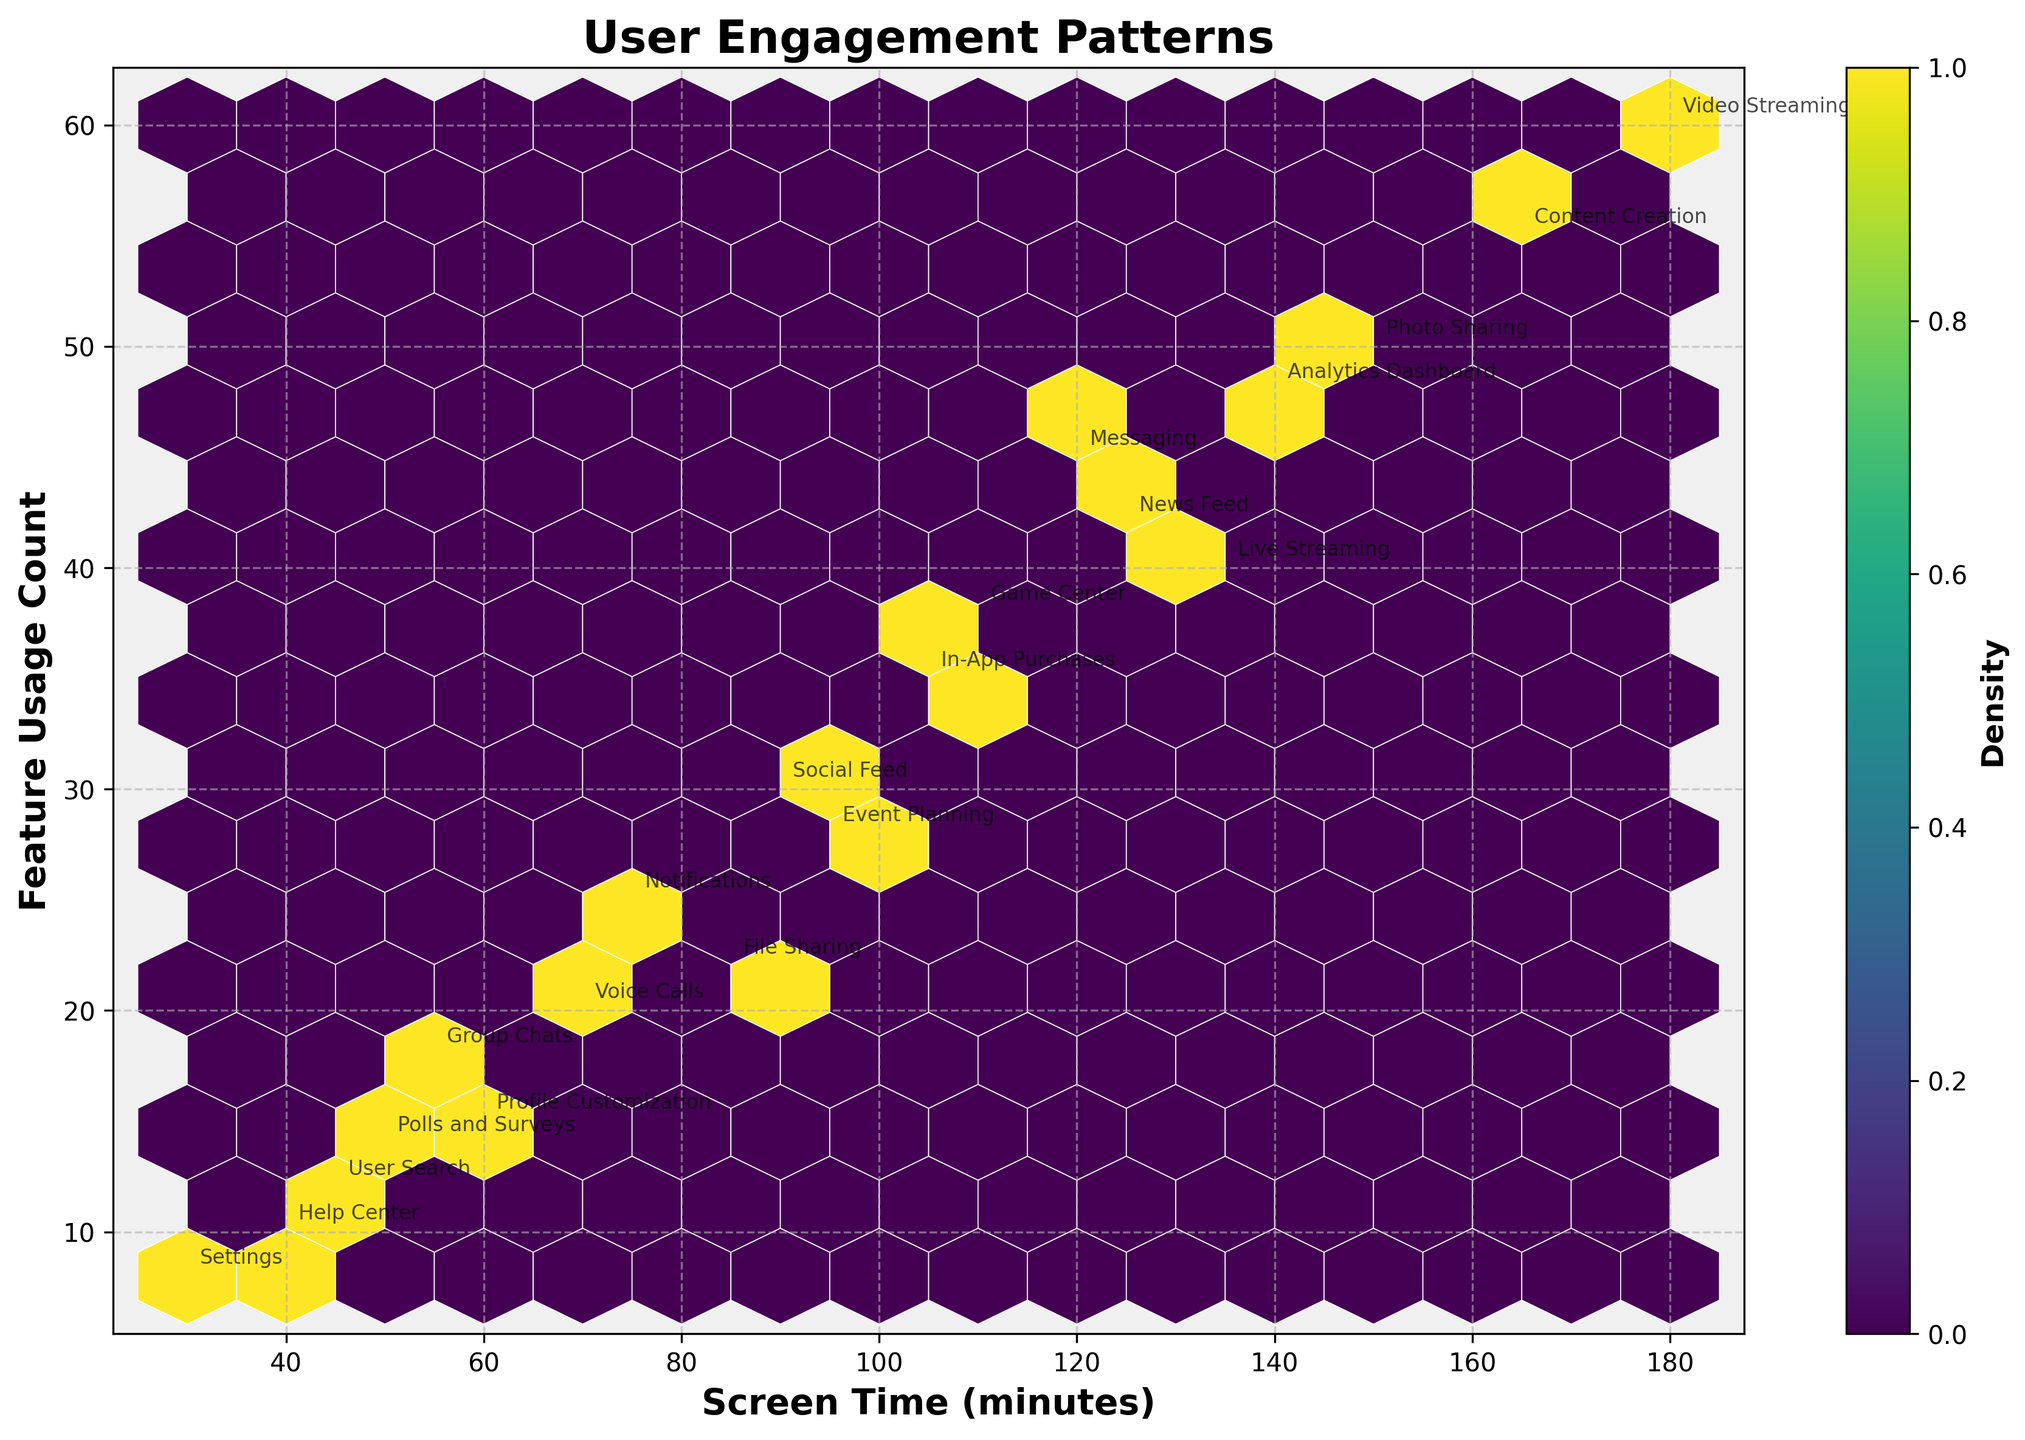What is the title of the figure? The title is located at the top of the figure. It is clearly labeled and usually provides a quick summary of what the figure represents.
Answer: User Engagement Patterns What are the x-axis and y-axis labels? The x-axis label is along the horizontal axis and describes what the x-values represent, while the y-axis label is along the vertical axis and describes what the y-values represent.
Answer: Screen Time (minutes) and Feature Usage Count Which feature has the highest screen time? Locate the data point that is farthest to the right on the x-axis, indicating the maximum screen time value. Identify the corresponding feature name annotated beside it.
Answer: Video Streaming How many features have a screen time greater than 100 minutes? Count the number of data points that lie to the right of the 100 minutes mark on the x-axis.
Answer: 9 What feature is associated with a feature usage count of 35? Look for the data point marked at y = 35 on the y-axis and check the annotation for the feature name.
Answer: In-App Purchases Which feature shows the lowest feature usage count? Find the data point that is lowest on the y-axis, indicating the minimum feature usage count. Identify the feature name annotated beside this point.
Answer: Settings What is the average screen time for features with more than 40 feature usage counts? Identify the data points with feature usage counts greater than 40, sum their screen times, and divide by the number of such points. (120 + 180 + 150 + 165 + 125 + 140) = 880; 880 / 6 = 146.67
Answer: 146.67 How does the density of features change as screen time increases? Observe the color gradient and distribution pattern in the hexbin plot to understand how density varies with increasing screen time.
Answer: Density increases up to a certain point and then decreases Which two features have the most similar usage patterns in terms of screen time and feature usage count? Look for two data points that are closest to each other on the plot and note their respective feature names from the annotations.
Answer: In-App Purchases and News Feed Are there more data points with screen time below 100 minutes or above 100 minutes? Count the number of data points on either side of the 100 minutes mark on the x-axis and compare.
Answer: More above 100 minutes 